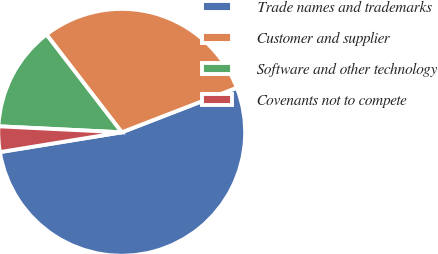<chart> <loc_0><loc_0><loc_500><loc_500><pie_chart><fcel>Trade names and trademarks<fcel>Customer and supplier<fcel>Software and other technology<fcel>Covenants not to compete<nl><fcel>53.32%<fcel>29.57%<fcel>13.78%<fcel>3.34%<nl></chart> 